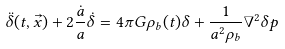<formula> <loc_0><loc_0><loc_500><loc_500>\ddot { \delta } ( t , \vec { x } ) + 2 \frac { \dot { a } } { a } \dot { \delta } = 4 \pi G \rho _ { b } ( t ) \delta + \frac { 1 } { a ^ { 2 } \rho _ { b } } \nabla ^ { 2 } \delta p</formula> 